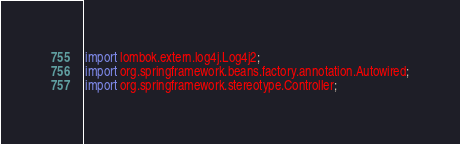<code> <loc_0><loc_0><loc_500><loc_500><_Java_>import lombok.extern.log4j.Log4j2;
import org.springframework.beans.factory.annotation.Autowired;
import org.springframework.stereotype.Controller;</code> 